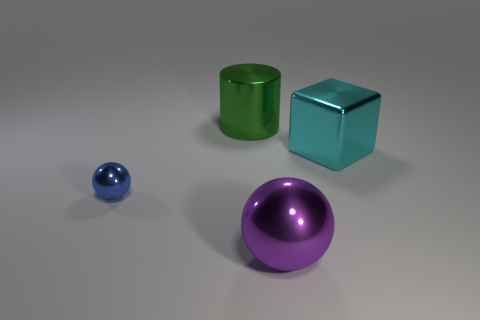Add 4 big blocks. How many objects exist? 8 Subtract all cubes. How many objects are left? 3 Subtract 0 blue cylinders. How many objects are left? 4 Subtract all big yellow cubes. Subtract all shiny spheres. How many objects are left? 2 Add 2 big cyan shiny objects. How many big cyan shiny objects are left? 3 Add 3 brown rubber spheres. How many brown rubber spheres exist? 3 